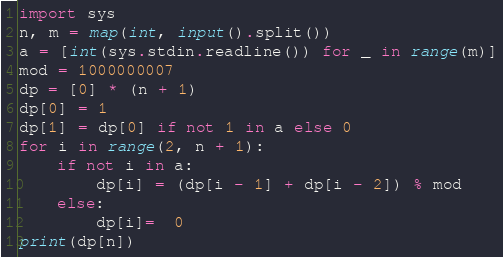Convert code to text. <code><loc_0><loc_0><loc_500><loc_500><_Python_>import sys
n, m = map(int, input().split())
a = [int(sys.stdin.readline()) for _ in range(m)]
mod = 1000000007
dp = [0] * (n + 1)
dp[0] = 1
dp[1] = dp[0] if not 1 in a else 0
for i in range(2, n + 1):
    if not i in a:
        dp[i] = (dp[i - 1] + dp[i - 2]) % mod
    else:
        dp[i]=  0
print(dp[n])
</code> 